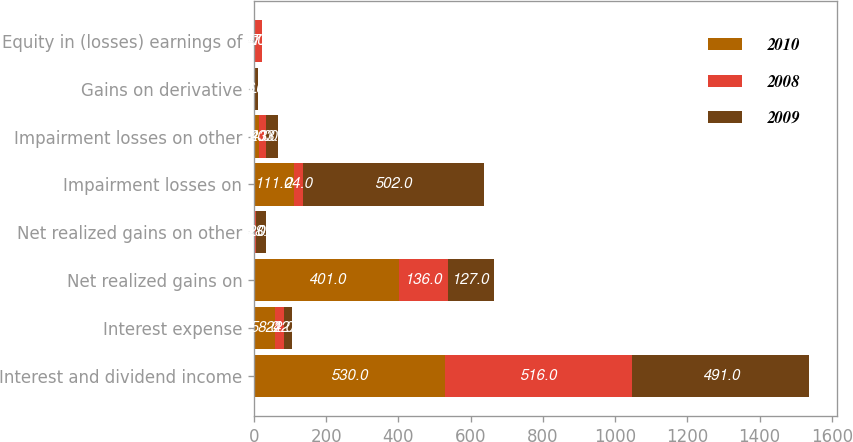Convert chart. <chart><loc_0><loc_0><loc_500><loc_500><stacked_bar_chart><ecel><fcel>Interest and dividend income<fcel>Interest expense<fcel>Net realized gains on<fcel>Net realized gains on other<fcel>Impairment losses on<fcel>Impairment losses on other<fcel>Gains on derivative<fcel>Equity in (losses) earnings of<nl><fcel>2010<fcel>530<fcel>58<fcel>401<fcel>4<fcel>111<fcel>14<fcel>3<fcel>4<nl><fcel>2008<fcel>516<fcel>24<fcel>136<fcel>1<fcel>24<fcel>20<fcel>1<fcel>17<nl><fcel>2009<fcel>491<fcel>22<fcel>127<fcel>28<fcel>502<fcel>33<fcel>6<fcel>1<nl></chart> 